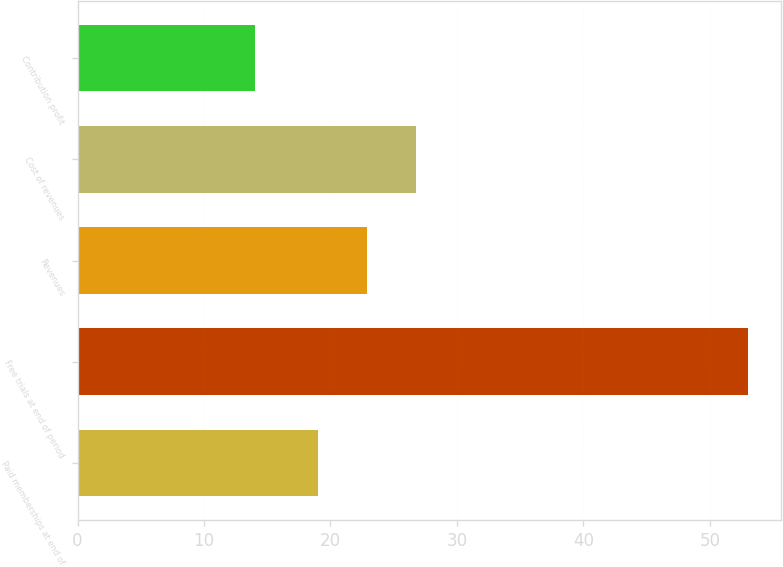Convert chart to OTSL. <chart><loc_0><loc_0><loc_500><loc_500><bar_chart><fcel>Paid memberships at end of<fcel>Free trials at end of period<fcel>Revenues<fcel>Cost of revenues<fcel>Contribution profit<nl><fcel>19<fcel>53<fcel>22.9<fcel>26.8<fcel>14<nl></chart> 